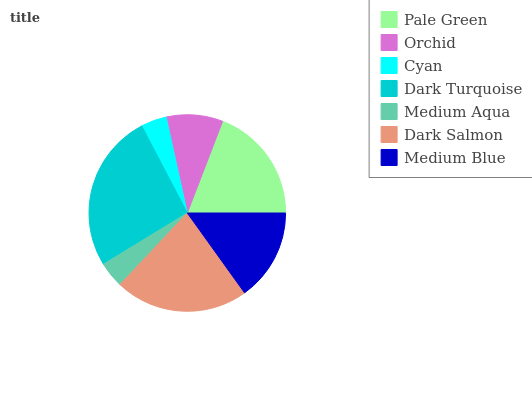Is Cyan the minimum?
Answer yes or no. Yes. Is Dark Turquoise the maximum?
Answer yes or no. Yes. Is Orchid the minimum?
Answer yes or no. No. Is Orchid the maximum?
Answer yes or no. No. Is Pale Green greater than Orchid?
Answer yes or no. Yes. Is Orchid less than Pale Green?
Answer yes or no. Yes. Is Orchid greater than Pale Green?
Answer yes or no. No. Is Pale Green less than Orchid?
Answer yes or no. No. Is Medium Blue the high median?
Answer yes or no. Yes. Is Medium Blue the low median?
Answer yes or no. Yes. Is Medium Aqua the high median?
Answer yes or no. No. Is Cyan the low median?
Answer yes or no. No. 